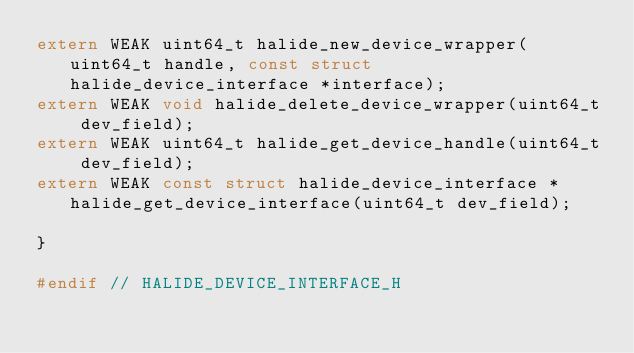Convert code to text. <code><loc_0><loc_0><loc_500><loc_500><_C_>extern WEAK uint64_t halide_new_device_wrapper(uint64_t handle, const struct halide_device_interface *interface);
extern WEAK void halide_delete_device_wrapper(uint64_t dev_field);
extern WEAK uint64_t halide_get_device_handle(uint64_t dev_field);
extern WEAK const struct halide_device_interface *halide_get_device_interface(uint64_t dev_field);

}

#endif // HALIDE_DEVICE_INTERFACE_H
</code> 